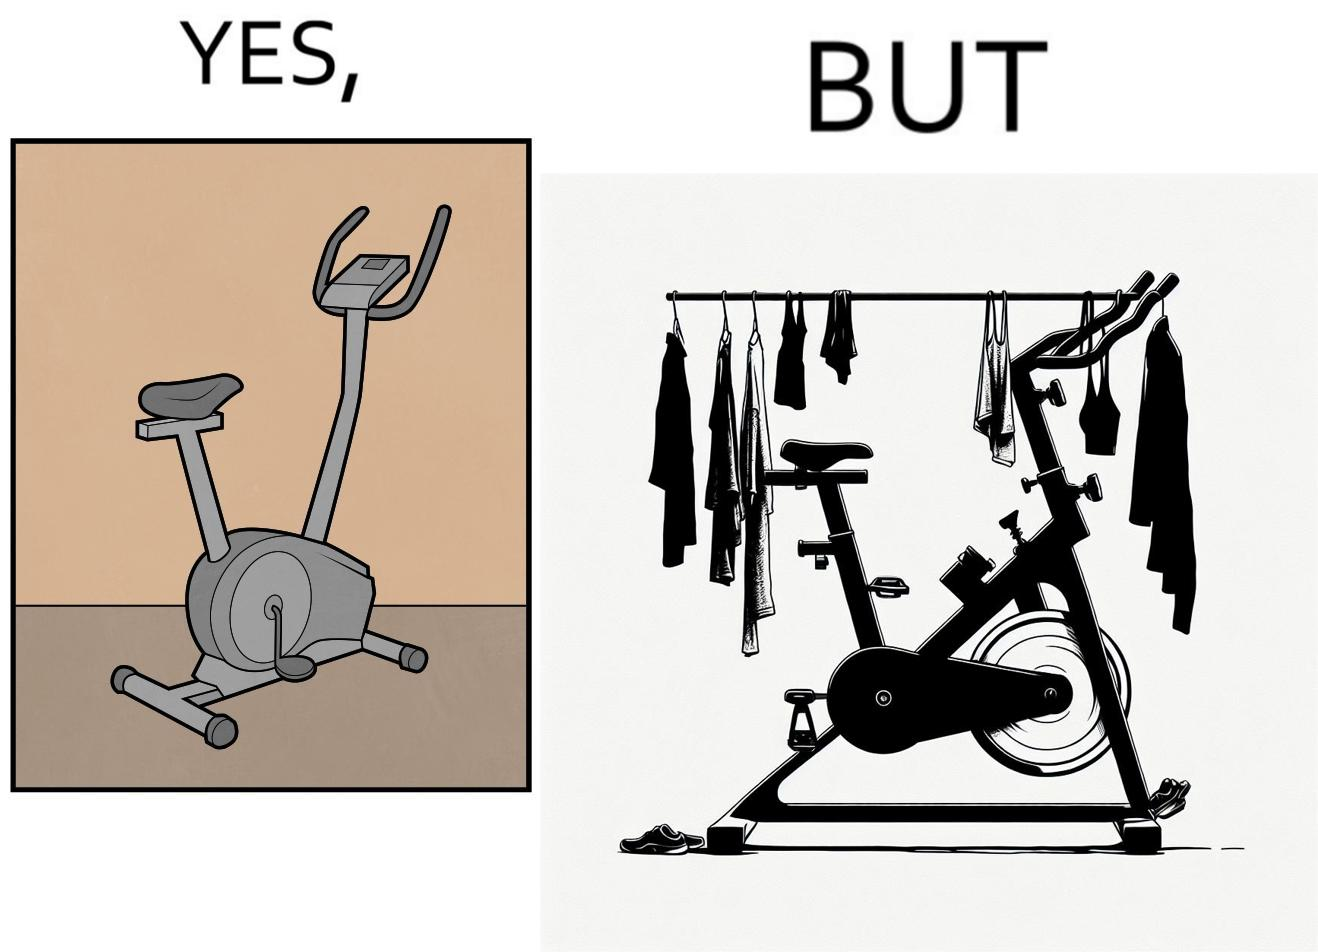Provide a description of this image. The images are funny since they show an exercise bike has been bought but is not being used for its purpose, that is, exercising. It is rather being used to hang clothes, bags and other items 